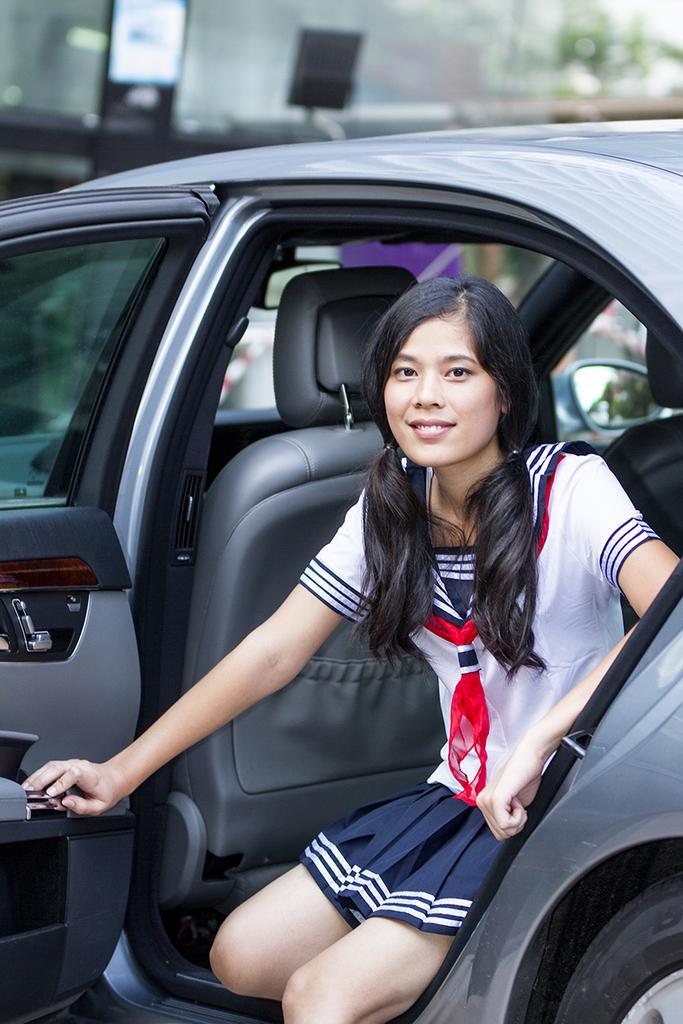Can you describe this image briefly? In this image I can see a person sitting inside the car. 